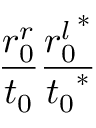<formula> <loc_0><loc_0><loc_500><loc_500>\frac { r _ { 0 } ^ { r } } { t _ { 0 } } \frac { { r _ { 0 } ^ { l } } ^ { * } } { { t _ { 0 } } ^ { * } }</formula> 